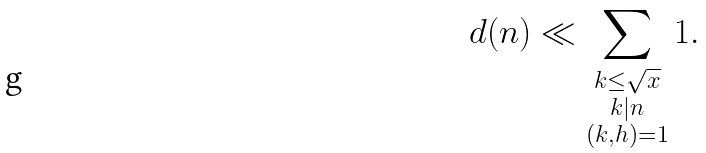Convert formula to latex. <formula><loc_0><loc_0><loc_500><loc_500>d ( n ) \ll \sum _ { \substack { k \leq \sqrt { x } \\ k | n \\ ( k , h ) = 1 } } 1 .</formula> 